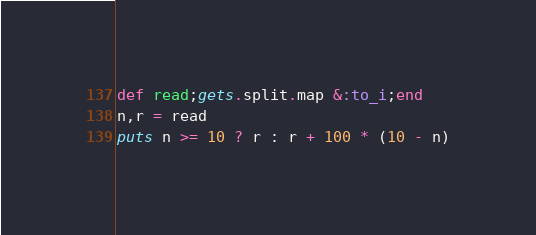Convert code to text. <code><loc_0><loc_0><loc_500><loc_500><_Ruby_>def read;gets.split.map &:to_i;end
n,r = read
puts n >= 10 ? r : r + 100 * (10 - n)
</code> 